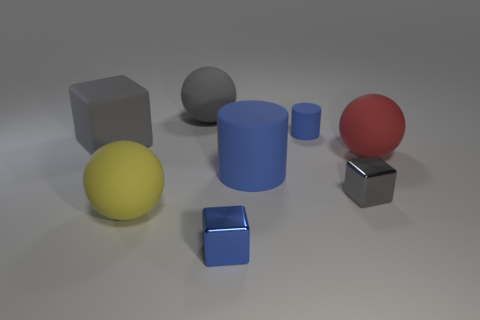Can you describe how the lighting affects the appearance of the objects? The even and soft lighting casts gentle shadows and subtly highlights the textures of the objects, giving the scene a calm and balanced ambiance. Is there a pattern in the arrangement of the objects? While there isn't a strict pattern, the objects form an informal arc from left to right, leading the viewer's eye through the image and creating a sense of casual order. 